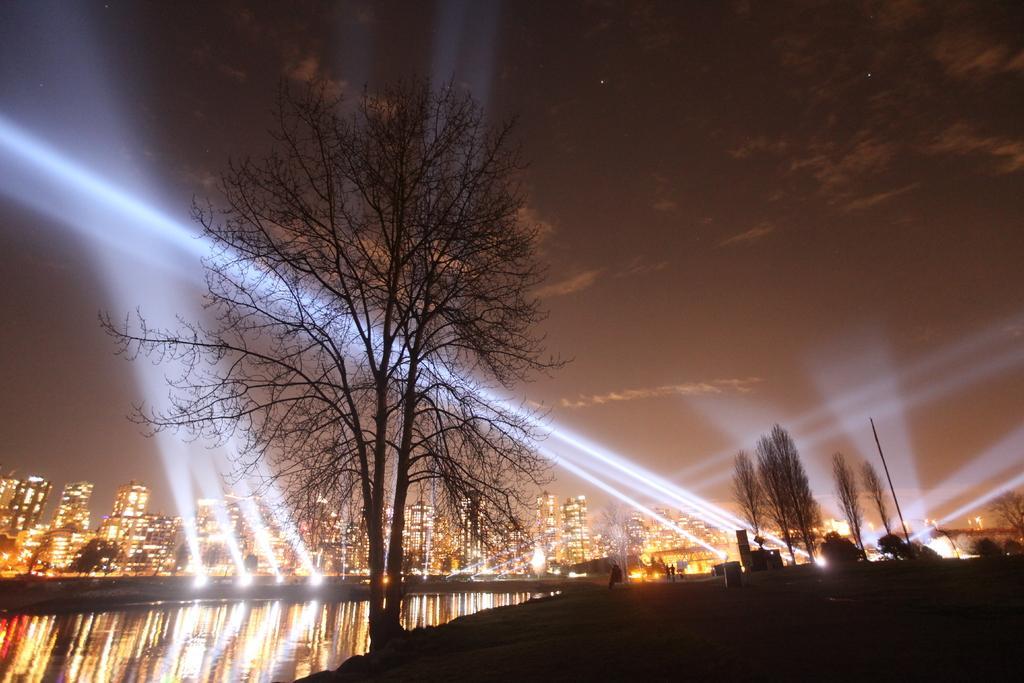Describe this image in one or two sentences. In this image we can see number of trees and a lake and in the background we can see lights and a city with full of buildings. We can also see sky of night view. 